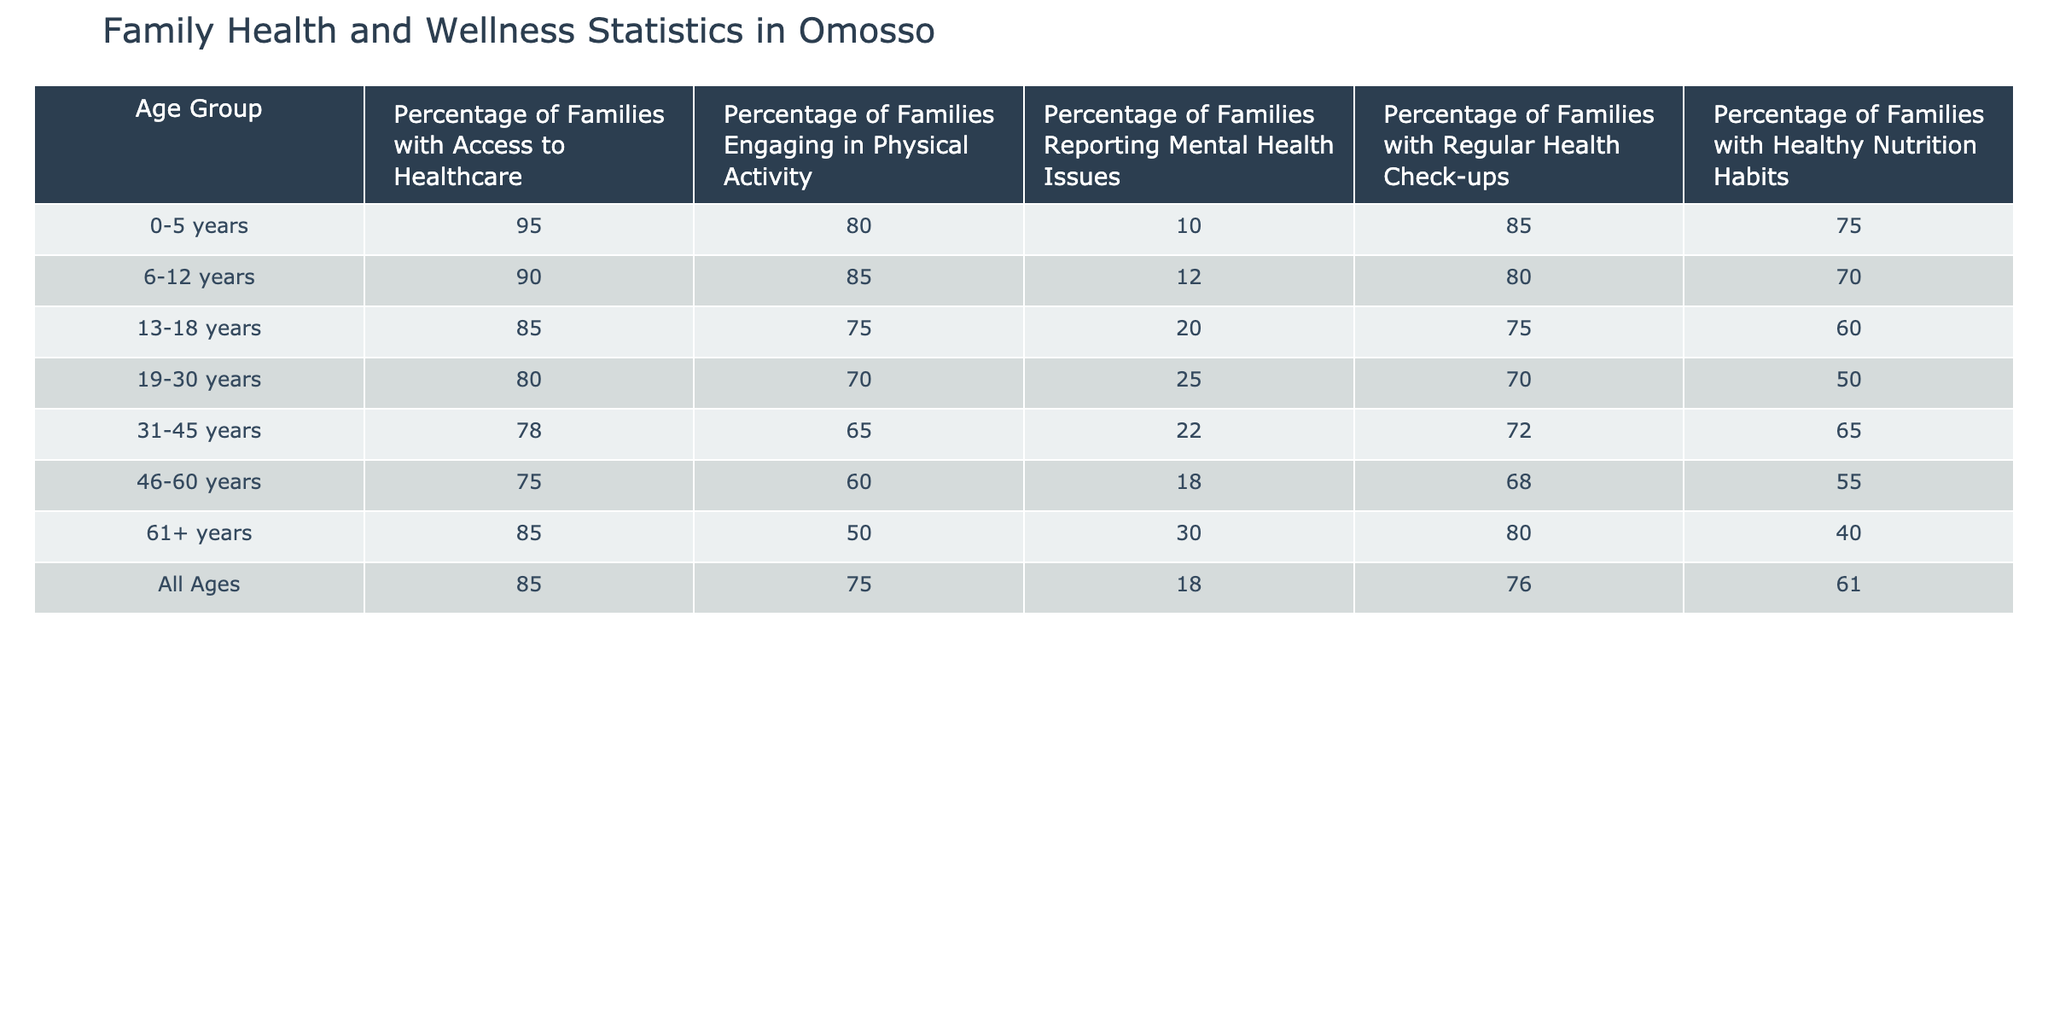What percentage of families with children aged 0-5 years have access to healthcare? The table shows that the percentage of families with access to healthcare for the 0-5 years age group is given directly as 95%.
Answer: 95% What is the percentage of families with healthy nutrition habits in the 19-30 years age group? According to the table, the percentage of families with healthy nutrition habits for the 19-30 years age group is 50%.
Answer: 50% Which age group has the highest percentage of families engaging in physical activity? By reviewing the percentages in the physical activity column, the 6-12 years age group has the highest percentage at 85%.
Answer: 6-12 years What is the difference in the percentage of families reporting mental health issues between the 13-18 years and 31-45 years age groups? The percentage of families reporting mental health issues in the 13-18 years age group is 20% and in the 31-45 years age group is 22%. The difference is 22% - 20% = 2%.
Answer: 2% Do more families in the 46-60 years group have regular health check-ups compared to the 19-30 years group? For the 46-60 years group, 68% have regular health check-ups, while 70% of the 19-30 years group do. Since 68% is less than 70%, the statement is false.
Answer: No What is the average percentage of families with access to healthcare across all age groups? To find the average, sum the percentages for all age groups: (95 + 90 + 85 + 80 + 78 + 75 + 85) = 600. Then divide by the number of groups (7): 600 / 7 ≈ 85.71%.
Answer: 85.71% Which age group has the lowest percentage of families with healthy nutrition habits? By examining the healthy nutrition habits column, the 61+ years age group shows a percentage of 40%, which is lower than all other age groups.
Answer: 61+ years What is the percentage of families with access to healthcare for the "All Ages" category? The table specifies that for all ages, the percentage of families with access to healthcare is 85%.
Answer: 85% How many percentage points difference exists between families engaging in physical activity in the 0-5 years and 61+ years age groups? The 0-5 years age group has 80% engaging in physical activity, while the 61+ years group has 50%. The difference is calculated as 80% - 50% = 30 percentage points.
Answer: 30 What percentage of families engaged in physical activity is there compared to those reporting mental health issues in the 31-45 years age group? The physical activity percentage for the 31-45 years group is 65% and the mental health issue reporting is 22%. The comparison shows that a higher percentage of families engage in physical activity.
Answer: Yes, more engage in physical activity What percentage of families with children aged 6-12 years have regular health check-ups? From the table, the percentage of families in the 6-12 years age group with regular health check-ups is 80%.
Answer: 80% 